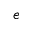Convert formula to latex. <formula><loc_0><loc_0><loc_500><loc_500>e</formula> 